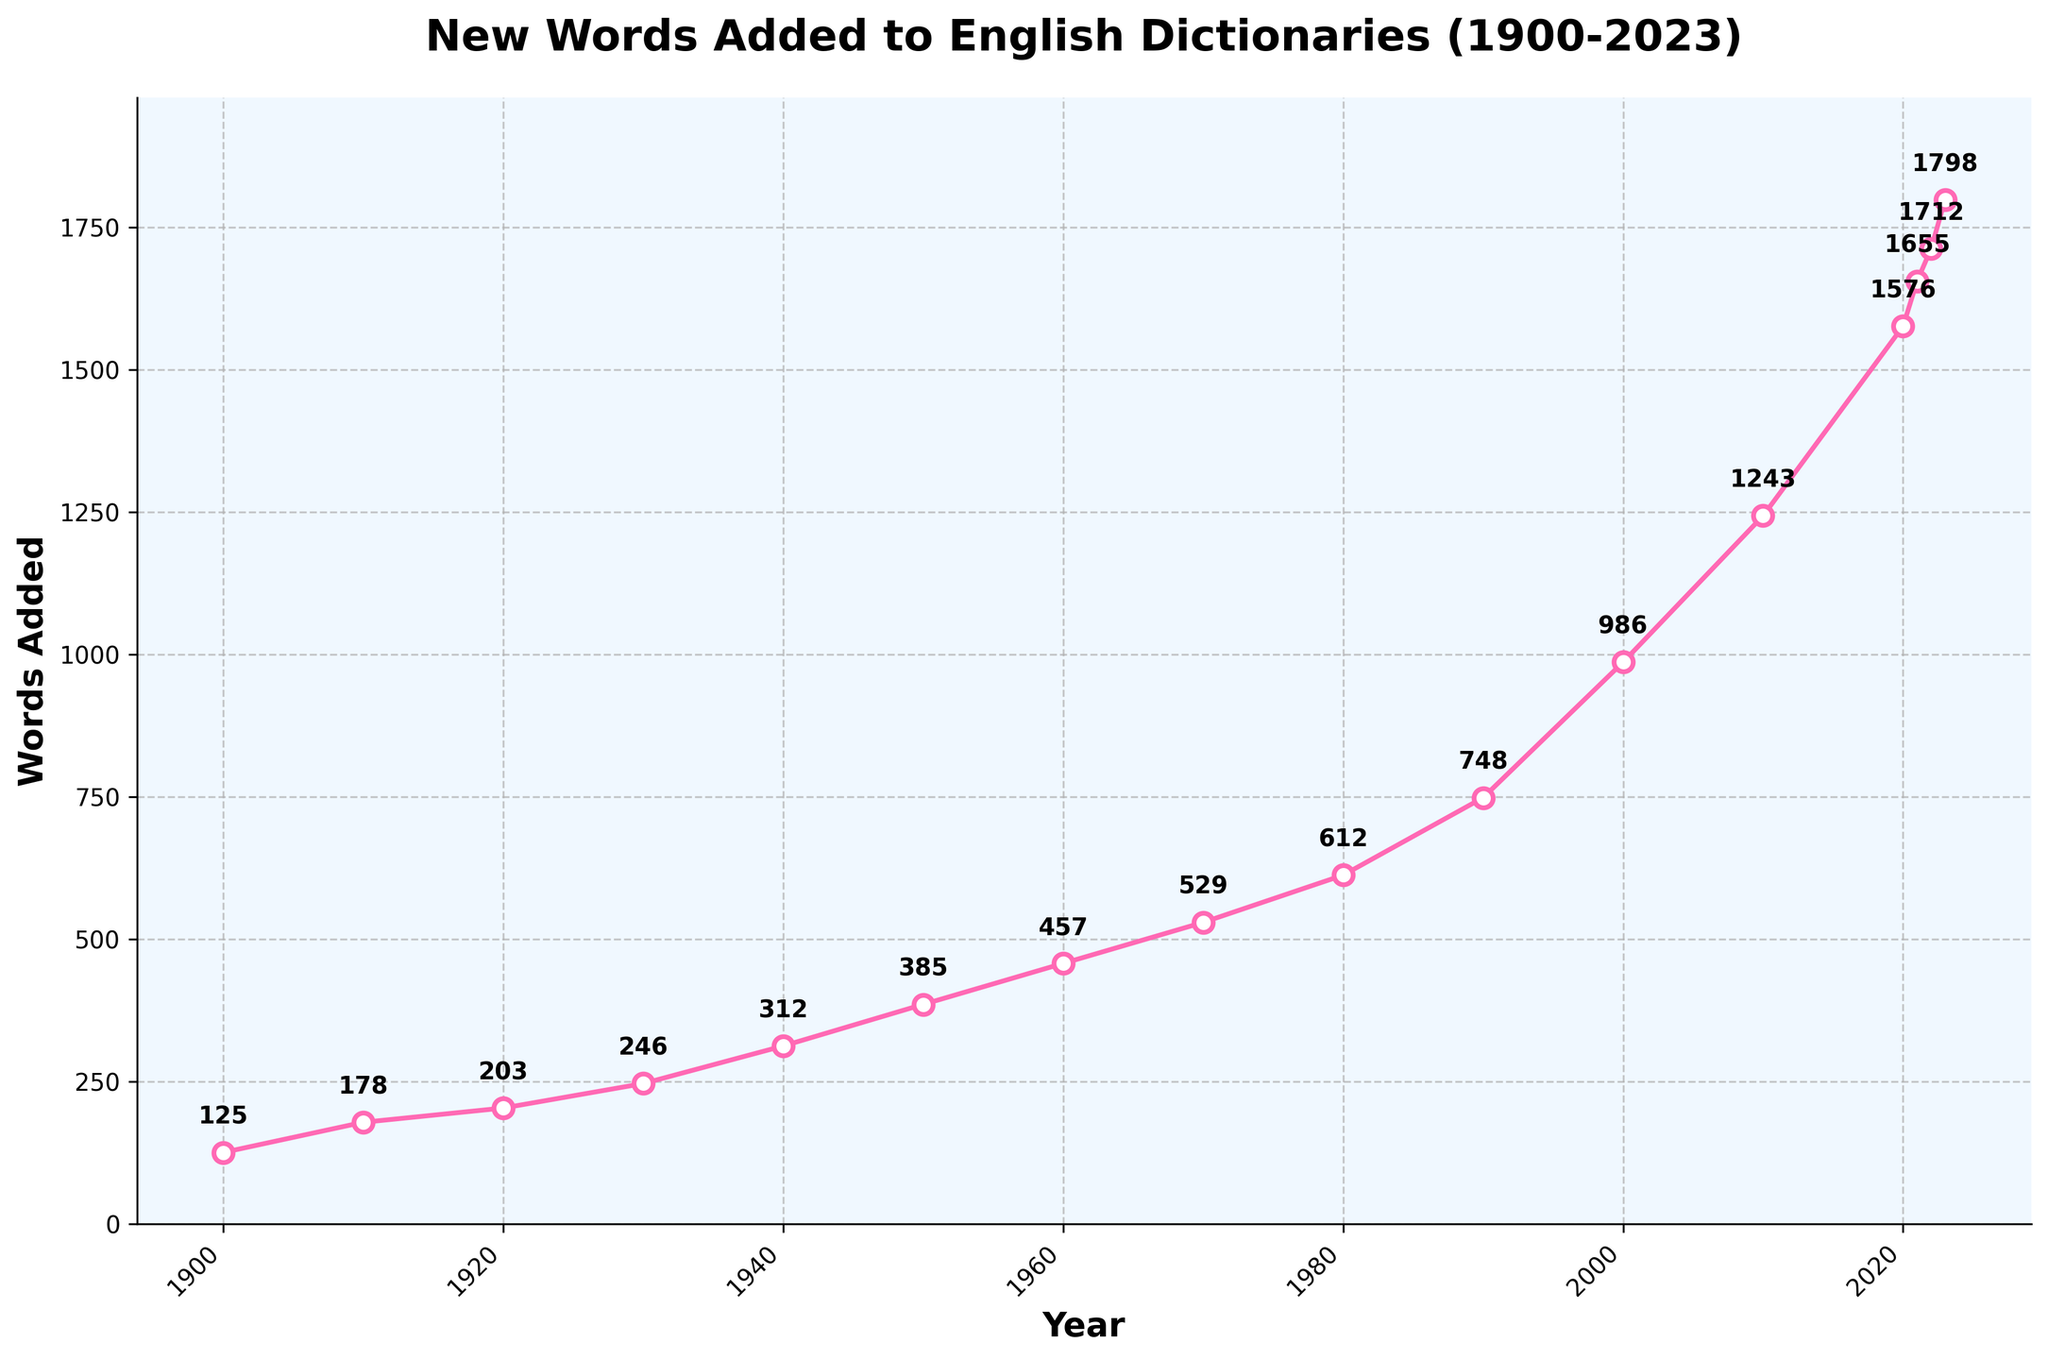What is the total number of new words added to the English dictionaries between 1900 and 1950? To find the total number, sum the words added in years 1900, 1910, 1920, 1930, 1940, and 1950: 125 + 178 + 203 + 246 + 312 + 385 = 1449.
Answer: 1449 Which year saw the highest number of words added up to 2023? By looking at the peaks in the chart, 2023 has the highest value of 1798 words added.
Answer: 2023 What is the average number of words added per year from 2000 to 2023? Calculate the average by summing the words added from 2000 to 2023, then dividing by the number of years: (986 + 1243 + 1576 + 1655 + 1712 + 1798) / 6 = 10970 / 6 ≈ 1828.33.
Answer: Approximately 1828.33 What is the difference in the number of words added between 1980 and 1990? Subtract the words added in 1980 from the words added in 1990: 748 - 612 = 136.
Answer: 136 In which decade did the number of words added first exceed 500? Find the earliest year where the words added is greater than 500. This occurs in 1970 with 529 words.
Answer: 1970 Is there any significant visual pattern in the trend from 1900 to 2023? From the figure, there's a noticeable increasing trend where the number of words added accelerates significantly after 1950, with a more rapid increase from 1980 onwards.
Answer: Increasing trend, accelerates after 1950 How does the number of words added in 2010 compare to the number in 2020? Comparing the values, 1243 words were added in 2010 and 1576 in 2020. 2020 has more words added.
Answer: 2020 has more What was the rate of change in words added between 2000 and 2010? Compute the rate of change: (1243 - 986) / (2010 - 2000) = 257 / 10 = 25.7 words per year.
Answer: 25.7 words per year 